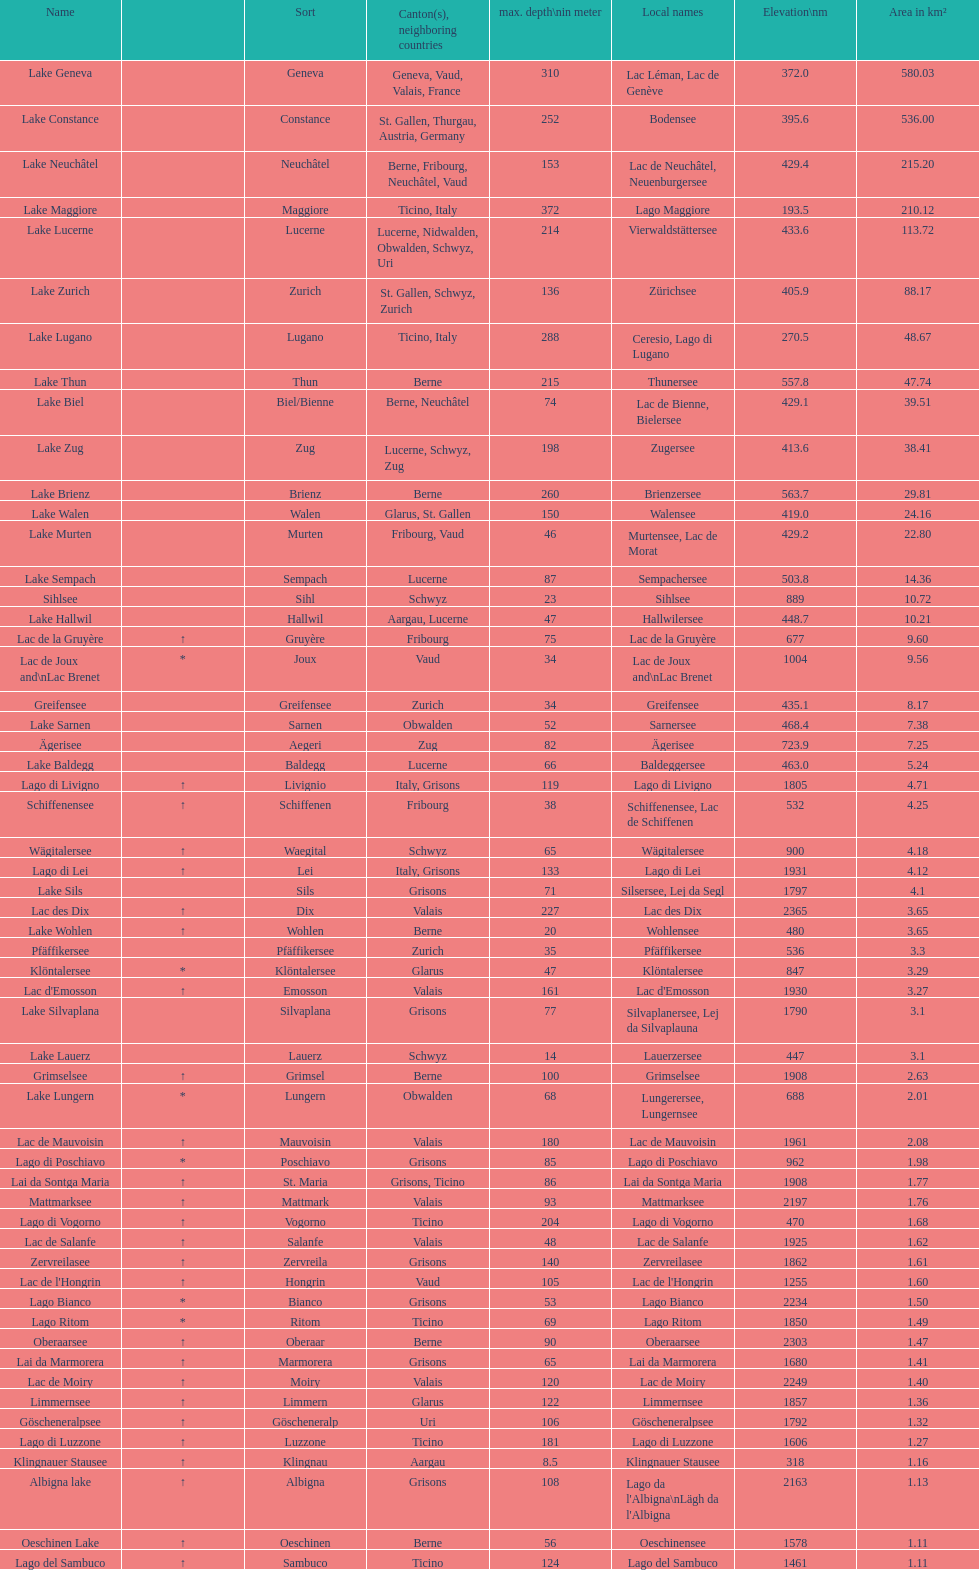Name the largest lake Lake Geneva. 